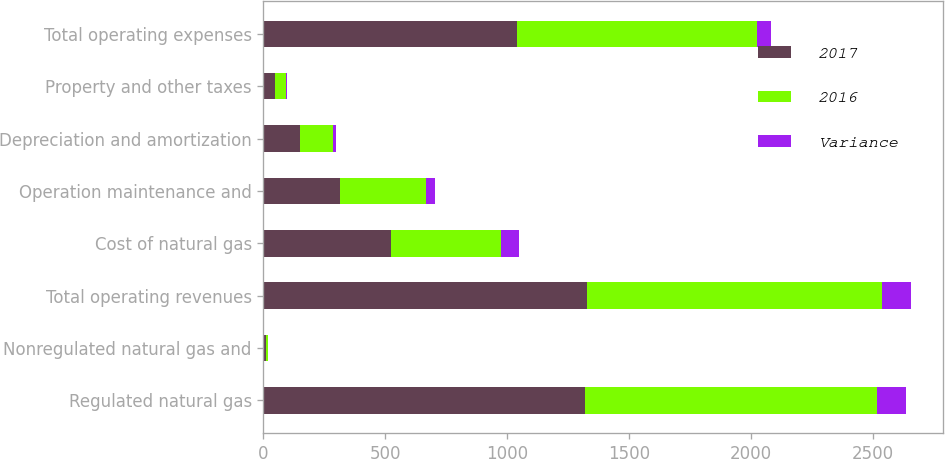Convert chart to OTSL. <chart><loc_0><loc_0><loc_500><loc_500><stacked_bar_chart><ecel><fcel>Regulated natural gas<fcel>Nonregulated natural gas and<fcel>Total operating revenues<fcel>Cost of natural gas<fcel>Operation maintenance and<fcel>Depreciation and amortization<fcel>Property and other taxes<fcel>Total operating expenses<nl><fcel>2017<fcel>1319<fcel>9<fcel>1328<fcel>524<fcel>315<fcel>148<fcel>48<fcel>1042<nl><fcel>2016<fcel>1201<fcel>10<fcel>1211<fcel>451<fcel>353<fcel>138<fcel>43<fcel>985<nl><fcel>Variance<fcel>118<fcel>1<fcel>117<fcel>73<fcel>38<fcel>10<fcel>5<fcel>57<nl></chart> 